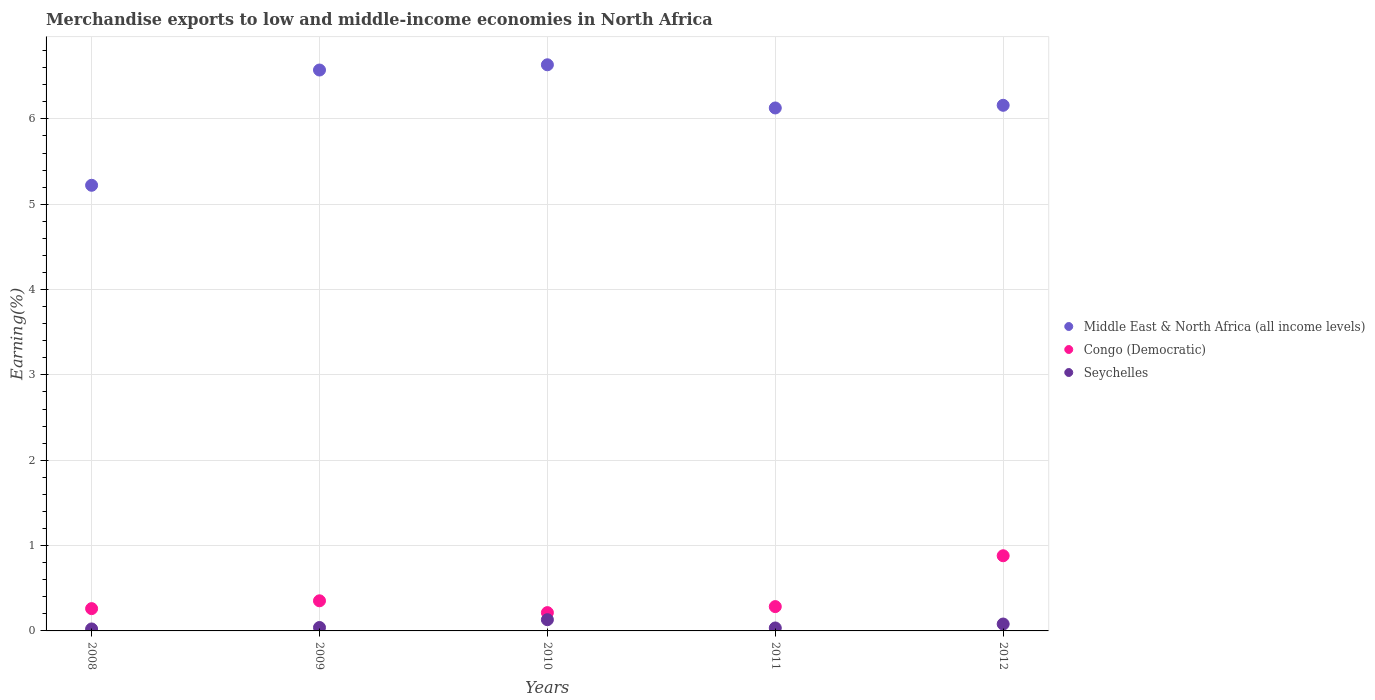What is the percentage of amount earned from merchandise exports in Seychelles in 2012?
Give a very brief answer. 0.08. Across all years, what is the maximum percentage of amount earned from merchandise exports in Middle East & North Africa (all income levels)?
Offer a very short reply. 6.63. Across all years, what is the minimum percentage of amount earned from merchandise exports in Middle East & North Africa (all income levels)?
Your answer should be very brief. 5.22. What is the total percentage of amount earned from merchandise exports in Congo (Democratic) in the graph?
Ensure brevity in your answer.  1.99. What is the difference between the percentage of amount earned from merchandise exports in Middle East & North Africa (all income levels) in 2011 and that in 2012?
Provide a succinct answer. -0.03. What is the difference between the percentage of amount earned from merchandise exports in Middle East & North Africa (all income levels) in 2011 and the percentage of amount earned from merchandise exports in Congo (Democratic) in 2010?
Offer a very short reply. 5.91. What is the average percentage of amount earned from merchandise exports in Congo (Democratic) per year?
Offer a terse response. 0.4. In the year 2011, what is the difference between the percentage of amount earned from merchandise exports in Middle East & North Africa (all income levels) and percentage of amount earned from merchandise exports in Congo (Democratic)?
Give a very brief answer. 5.84. What is the ratio of the percentage of amount earned from merchandise exports in Seychelles in 2010 to that in 2012?
Offer a very short reply. 1.63. Is the percentage of amount earned from merchandise exports in Middle East & North Africa (all income levels) in 2009 less than that in 2012?
Ensure brevity in your answer.  No. Is the difference between the percentage of amount earned from merchandise exports in Middle East & North Africa (all income levels) in 2009 and 2011 greater than the difference between the percentage of amount earned from merchandise exports in Congo (Democratic) in 2009 and 2011?
Make the answer very short. Yes. What is the difference between the highest and the second highest percentage of amount earned from merchandise exports in Middle East & North Africa (all income levels)?
Provide a succinct answer. 0.06. What is the difference between the highest and the lowest percentage of amount earned from merchandise exports in Middle East & North Africa (all income levels)?
Provide a succinct answer. 1.41. Does the percentage of amount earned from merchandise exports in Congo (Democratic) monotonically increase over the years?
Your answer should be very brief. No. Is the percentage of amount earned from merchandise exports in Middle East & North Africa (all income levels) strictly less than the percentage of amount earned from merchandise exports in Seychelles over the years?
Make the answer very short. No. How many dotlines are there?
Your answer should be compact. 3. How many years are there in the graph?
Give a very brief answer. 5. What is the difference between two consecutive major ticks on the Y-axis?
Your answer should be compact. 1. Are the values on the major ticks of Y-axis written in scientific E-notation?
Give a very brief answer. No. Where does the legend appear in the graph?
Offer a very short reply. Center right. What is the title of the graph?
Ensure brevity in your answer.  Merchandise exports to low and middle-income economies in North Africa. What is the label or title of the Y-axis?
Offer a terse response. Earning(%). What is the Earning(%) in Middle East & North Africa (all income levels) in 2008?
Your answer should be compact. 5.22. What is the Earning(%) in Congo (Democratic) in 2008?
Provide a succinct answer. 0.26. What is the Earning(%) in Seychelles in 2008?
Make the answer very short. 0.02. What is the Earning(%) of Middle East & North Africa (all income levels) in 2009?
Give a very brief answer. 6.57. What is the Earning(%) of Congo (Democratic) in 2009?
Provide a succinct answer. 0.35. What is the Earning(%) in Seychelles in 2009?
Your answer should be compact. 0.04. What is the Earning(%) of Middle East & North Africa (all income levels) in 2010?
Keep it short and to the point. 6.63. What is the Earning(%) of Congo (Democratic) in 2010?
Your response must be concise. 0.21. What is the Earning(%) of Seychelles in 2010?
Ensure brevity in your answer.  0.13. What is the Earning(%) in Middle East & North Africa (all income levels) in 2011?
Your response must be concise. 6.13. What is the Earning(%) of Congo (Democratic) in 2011?
Offer a terse response. 0.28. What is the Earning(%) in Seychelles in 2011?
Provide a short and direct response. 0.03. What is the Earning(%) in Middle East & North Africa (all income levels) in 2012?
Provide a succinct answer. 6.16. What is the Earning(%) in Congo (Democratic) in 2012?
Make the answer very short. 0.88. What is the Earning(%) in Seychelles in 2012?
Ensure brevity in your answer.  0.08. Across all years, what is the maximum Earning(%) in Middle East & North Africa (all income levels)?
Give a very brief answer. 6.63. Across all years, what is the maximum Earning(%) in Congo (Democratic)?
Your response must be concise. 0.88. Across all years, what is the maximum Earning(%) in Seychelles?
Ensure brevity in your answer.  0.13. Across all years, what is the minimum Earning(%) in Middle East & North Africa (all income levels)?
Make the answer very short. 5.22. Across all years, what is the minimum Earning(%) in Congo (Democratic)?
Offer a terse response. 0.21. Across all years, what is the minimum Earning(%) in Seychelles?
Keep it short and to the point. 0.02. What is the total Earning(%) of Middle East & North Africa (all income levels) in the graph?
Your response must be concise. 30.72. What is the total Earning(%) of Congo (Democratic) in the graph?
Your response must be concise. 1.99. What is the total Earning(%) of Seychelles in the graph?
Keep it short and to the point. 0.31. What is the difference between the Earning(%) in Middle East & North Africa (all income levels) in 2008 and that in 2009?
Offer a very short reply. -1.35. What is the difference between the Earning(%) in Congo (Democratic) in 2008 and that in 2009?
Provide a short and direct response. -0.09. What is the difference between the Earning(%) in Seychelles in 2008 and that in 2009?
Keep it short and to the point. -0.02. What is the difference between the Earning(%) of Middle East & North Africa (all income levels) in 2008 and that in 2010?
Your answer should be very brief. -1.41. What is the difference between the Earning(%) of Congo (Democratic) in 2008 and that in 2010?
Provide a succinct answer. 0.05. What is the difference between the Earning(%) in Seychelles in 2008 and that in 2010?
Keep it short and to the point. -0.11. What is the difference between the Earning(%) of Middle East & North Africa (all income levels) in 2008 and that in 2011?
Your answer should be compact. -0.91. What is the difference between the Earning(%) of Congo (Democratic) in 2008 and that in 2011?
Your response must be concise. -0.02. What is the difference between the Earning(%) of Seychelles in 2008 and that in 2011?
Your answer should be very brief. -0.01. What is the difference between the Earning(%) in Middle East & North Africa (all income levels) in 2008 and that in 2012?
Keep it short and to the point. -0.94. What is the difference between the Earning(%) in Congo (Democratic) in 2008 and that in 2012?
Offer a very short reply. -0.62. What is the difference between the Earning(%) of Seychelles in 2008 and that in 2012?
Give a very brief answer. -0.06. What is the difference between the Earning(%) in Middle East & North Africa (all income levels) in 2009 and that in 2010?
Ensure brevity in your answer.  -0.06. What is the difference between the Earning(%) of Congo (Democratic) in 2009 and that in 2010?
Make the answer very short. 0.14. What is the difference between the Earning(%) in Seychelles in 2009 and that in 2010?
Give a very brief answer. -0.09. What is the difference between the Earning(%) in Middle East & North Africa (all income levels) in 2009 and that in 2011?
Provide a succinct answer. 0.44. What is the difference between the Earning(%) in Congo (Democratic) in 2009 and that in 2011?
Make the answer very short. 0.07. What is the difference between the Earning(%) of Seychelles in 2009 and that in 2011?
Give a very brief answer. 0.01. What is the difference between the Earning(%) in Middle East & North Africa (all income levels) in 2009 and that in 2012?
Provide a succinct answer. 0.41. What is the difference between the Earning(%) in Congo (Democratic) in 2009 and that in 2012?
Ensure brevity in your answer.  -0.53. What is the difference between the Earning(%) in Seychelles in 2009 and that in 2012?
Keep it short and to the point. -0.04. What is the difference between the Earning(%) in Middle East & North Africa (all income levels) in 2010 and that in 2011?
Your answer should be compact. 0.51. What is the difference between the Earning(%) in Congo (Democratic) in 2010 and that in 2011?
Make the answer very short. -0.07. What is the difference between the Earning(%) of Seychelles in 2010 and that in 2011?
Your response must be concise. 0.1. What is the difference between the Earning(%) of Middle East & North Africa (all income levels) in 2010 and that in 2012?
Your answer should be compact. 0.47. What is the difference between the Earning(%) of Congo (Democratic) in 2010 and that in 2012?
Your answer should be very brief. -0.67. What is the difference between the Earning(%) in Seychelles in 2010 and that in 2012?
Make the answer very short. 0.05. What is the difference between the Earning(%) in Middle East & North Africa (all income levels) in 2011 and that in 2012?
Make the answer very short. -0.03. What is the difference between the Earning(%) in Congo (Democratic) in 2011 and that in 2012?
Offer a terse response. -0.6. What is the difference between the Earning(%) in Seychelles in 2011 and that in 2012?
Provide a short and direct response. -0.05. What is the difference between the Earning(%) in Middle East & North Africa (all income levels) in 2008 and the Earning(%) in Congo (Democratic) in 2009?
Offer a very short reply. 4.87. What is the difference between the Earning(%) in Middle East & North Africa (all income levels) in 2008 and the Earning(%) in Seychelles in 2009?
Provide a short and direct response. 5.18. What is the difference between the Earning(%) of Congo (Democratic) in 2008 and the Earning(%) of Seychelles in 2009?
Give a very brief answer. 0.22. What is the difference between the Earning(%) of Middle East & North Africa (all income levels) in 2008 and the Earning(%) of Congo (Democratic) in 2010?
Offer a terse response. 5.01. What is the difference between the Earning(%) in Middle East & North Africa (all income levels) in 2008 and the Earning(%) in Seychelles in 2010?
Your answer should be very brief. 5.09. What is the difference between the Earning(%) in Congo (Democratic) in 2008 and the Earning(%) in Seychelles in 2010?
Keep it short and to the point. 0.13. What is the difference between the Earning(%) in Middle East & North Africa (all income levels) in 2008 and the Earning(%) in Congo (Democratic) in 2011?
Provide a succinct answer. 4.94. What is the difference between the Earning(%) of Middle East & North Africa (all income levels) in 2008 and the Earning(%) of Seychelles in 2011?
Provide a succinct answer. 5.19. What is the difference between the Earning(%) in Congo (Democratic) in 2008 and the Earning(%) in Seychelles in 2011?
Your answer should be compact. 0.23. What is the difference between the Earning(%) in Middle East & North Africa (all income levels) in 2008 and the Earning(%) in Congo (Democratic) in 2012?
Keep it short and to the point. 4.34. What is the difference between the Earning(%) of Middle East & North Africa (all income levels) in 2008 and the Earning(%) of Seychelles in 2012?
Your response must be concise. 5.14. What is the difference between the Earning(%) in Congo (Democratic) in 2008 and the Earning(%) in Seychelles in 2012?
Your response must be concise. 0.18. What is the difference between the Earning(%) in Middle East & North Africa (all income levels) in 2009 and the Earning(%) in Congo (Democratic) in 2010?
Your answer should be very brief. 6.36. What is the difference between the Earning(%) of Middle East & North Africa (all income levels) in 2009 and the Earning(%) of Seychelles in 2010?
Your answer should be very brief. 6.44. What is the difference between the Earning(%) of Congo (Democratic) in 2009 and the Earning(%) of Seychelles in 2010?
Offer a terse response. 0.22. What is the difference between the Earning(%) of Middle East & North Africa (all income levels) in 2009 and the Earning(%) of Congo (Democratic) in 2011?
Offer a very short reply. 6.29. What is the difference between the Earning(%) of Middle East & North Africa (all income levels) in 2009 and the Earning(%) of Seychelles in 2011?
Give a very brief answer. 6.54. What is the difference between the Earning(%) of Congo (Democratic) in 2009 and the Earning(%) of Seychelles in 2011?
Your answer should be very brief. 0.32. What is the difference between the Earning(%) in Middle East & North Africa (all income levels) in 2009 and the Earning(%) in Congo (Democratic) in 2012?
Your response must be concise. 5.69. What is the difference between the Earning(%) in Middle East & North Africa (all income levels) in 2009 and the Earning(%) in Seychelles in 2012?
Offer a very short reply. 6.49. What is the difference between the Earning(%) of Congo (Democratic) in 2009 and the Earning(%) of Seychelles in 2012?
Your answer should be compact. 0.27. What is the difference between the Earning(%) in Middle East & North Africa (all income levels) in 2010 and the Earning(%) in Congo (Democratic) in 2011?
Give a very brief answer. 6.35. What is the difference between the Earning(%) of Middle East & North Africa (all income levels) in 2010 and the Earning(%) of Seychelles in 2011?
Your answer should be very brief. 6.6. What is the difference between the Earning(%) of Congo (Democratic) in 2010 and the Earning(%) of Seychelles in 2011?
Give a very brief answer. 0.18. What is the difference between the Earning(%) in Middle East & North Africa (all income levels) in 2010 and the Earning(%) in Congo (Democratic) in 2012?
Give a very brief answer. 5.75. What is the difference between the Earning(%) of Middle East & North Africa (all income levels) in 2010 and the Earning(%) of Seychelles in 2012?
Your answer should be very brief. 6.55. What is the difference between the Earning(%) in Congo (Democratic) in 2010 and the Earning(%) in Seychelles in 2012?
Your answer should be very brief. 0.13. What is the difference between the Earning(%) of Middle East & North Africa (all income levels) in 2011 and the Earning(%) of Congo (Democratic) in 2012?
Offer a very short reply. 5.25. What is the difference between the Earning(%) in Middle East & North Africa (all income levels) in 2011 and the Earning(%) in Seychelles in 2012?
Your response must be concise. 6.05. What is the difference between the Earning(%) in Congo (Democratic) in 2011 and the Earning(%) in Seychelles in 2012?
Ensure brevity in your answer.  0.2. What is the average Earning(%) in Middle East & North Africa (all income levels) per year?
Keep it short and to the point. 6.14. What is the average Earning(%) of Congo (Democratic) per year?
Your answer should be compact. 0.4. What is the average Earning(%) in Seychelles per year?
Ensure brevity in your answer.  0.06. In the year 2008, what is the difference between the Earning(%) in Middle East & North Africa (all income levels) and Earning(%) in Congo (Democratic)?
Ensure brevity in your answer.  4.96. In the year 2008, what is the difference between the Earning(%) in Middle East & North Africa (all income levels) and Earning(%) in Seychelles?
Give a very brief answer. 5.2. In the year 2008, what is the difference between the Earning(%) of Congo (Democratic) and Earning(%) of Seychelles?
Provide a short and direct response. 0.24. In the year 2009, what is the difference between the Earning(%) in Middle East & North Africa (all income levels) and Earning(%) in Congo (Democratic)?
Your response must be concise. 6.22. In the year 2009, what is the difference between the Earning(%) in Middle East & North Africa (all income levels) and Earning(%) in Seychelles?
Make the answer very short. 6.53. In the year 2009, what is the difference between the Earning(%) of Congo (Democratic) and Earning(%) of Seychelles?
Your answer should be very brief. 0.31. In the year 2010, what is the difference between the Earning(%) of Middle East & North Africa (all income levels) and Earning(%) of Congo (Democratic)?
Give a very brief answer. 6.42. In the year 2010, what is the difference between the Earning(%) in Middle East & North Africa (all income levels) and Earning(%) in Seychelles?
Ensure brevity in your answer.  6.5. In the year 2010, what is the difference between the Earning(%) of Congo (Democratic) and Earning(%) of Seychelles?
Give a very brief answer. 0.08. In the year 2011, what is the difference between the Earning(%) of Middle East & North Africa (all income levels) and Earning(%) of Congo (Democratic)?
Provide a succinct answer. 5.84. In the year 2011, what is the difference between the Earning(%) of Middle East & North Africa (all income levels) and Earning(%) of Seychelles?
Ensure brevity in your answer.  6.09. In the year 2011, what is the difference between the Earning(%) of Congo (Democratic) and Earning(%) of Seychelles?
Offer a terse response. 0.25. In the year 2012, what is the difference between the Earning(%) of Middle East & North Africa (all income levels) and Earning(%) of Congo (Democratic)?
Your response must be concise. 5.28. In the year 2012, what is the difference between the Earning(%) of Middle East & North Africa (all income levels) and Earning(%) of Seychelles?
Your answer should be very brief. 6.08. What is the ratio of the Earning(%) of Middle East & North Africa (all income levels) in 2008 to that in 2009?
Provide a succinct answer. 0.79. What is the ratio of the Earning(%) in Congo (Democratic) in 2008 to that in 2009?
Your answer should be compact. 0.74. What is the ratio of the Earning(%) of Seychelles in 2008 to that in 2009?
Your response must be concise. 0.58. What is the ratio of the Earning(%) of Middle East & North Africa (all income levels) in 2008 to that in 2010?
Ensure brevity in your answer.  0.79. What is the ratio of the Earning(%) of Congo (Democratic) in 2008 to that in 2010?
Your answer should be compact. 1.22. What is the ratio of the Earning(%) of Seychelles in 2008 to that in 2010?
Keep it short and to the point. 0.18. What is the ratio of the Earning(%) of Middle East & North Africa (all income levels) in 2008 to that in 2011?
Ensure brevity in your answer.  0.85. What is the ratio of the Earning(%) of Congo (Democratic) in 2008 to that in 2011?
Ensure brevity in your answer.  0.92. What is the ratio of the Earning(%) in Seychelles in 2008 to that in 2011?
Make the answer very short. 0.67. What is the ratio of the Earning(%) of Middle East & North Africa (all income levels) in 2008 to that in 2012?
Keep it short and to the point. 0.85. What is the ratio of the Earning(%) in Congo (Democratic) in 2008 to that in 2012?
Provide a succinct answer. 0.3. What is the ratio of the Earning(%) in Seychelles in 2008 to that in 2012?
Your response must be concise. 0.29. What is the ratio of the Earning(%) in Congo (Democratic) in 2009 to that in 2010?
Give a very brief answer. 1.65. What is the ratio of the Earning(%) in Seychelles in 2009 to that in 2010?
Make the answer very short. 0.3. What is the ratio of the Earning(%) of Middle East & North Africa (all income levels) in 2009 to that in 2011?
Your answer should be compact. 1.07. What is the ratio of the Earning(%) in Congo (Democratic) in 2009 to that in 2011?
Your answer should be compact. 1.24. What is the ratio of the Earning(%) in Seychelles in 2009 to that in 2011?
Make the answer very short. 1.16. What is the ratio of the Earning(%) in Middle East & North Africa (all income levels) in 2009 to that in 2012?
Provide a short and direct response. 1.07. What is the ratio of the Earning(%) in Congo (Democratic) in 2009 to that in 2012?
Offer a terse response. 0.4. What is the ratio of the Earning(%) of Seychelles in 2009 to that in 2012?
Provide a succinct answer. 0.5. What is the ratio of the Earning(%) of Middle East & North Africa (all income levels) in 2010 to that in 2011?
Provide a short and direct response. 1.08. What is the ratio of the Earning(%) of Congo (Democratic) in 2010 to that in 2011?
Give a very brief answer. 0.75. What is the ratio of the Earning(%) of Seychelles in 2010 to that in 2011?
Provide a short and direct response. 3.8. What is the ratio of the Earning(%) of Middle East & North Africa (all income levels) in 2010 to that in 2012?
Keep it short and to the point. 1.08. What is the ratio of the Earning(%) of Congo (Democratic) in 2010 to that in 2012?
Your answer should be very brief. 0.24. What is the ratio of the Earning(%) of Seychelles in 2010 to that in 2012?
Your answer should be compact. 1.63. What is the ratio of the Earning(%) of Congo (Democratic) in 2011 to that in 2012?
Provide a short and direct response. 0.32. What is the ratio of the Earning(%) of Seychelles in 2011 to that in 2012?
Offer a terse response. 0.43. What is the difference between the highest and the second highest Earning(%) of Middle East & North Africa (all income levels)?
Offer a terse response. 0.06. What is the difference between the highest and the second highest Earning(%) of Congo (Democratic)?
Ensure brevity in your answer.  0.53. What is the difference between the highest and the second highest Earning(%) of Seychelles?
Your response must be concise. 0.05. What is the difference between the highest and the lowest Earning(%) of Middle East & North Africa (all income levels)?
Ensure brevity in your answer.  1.41. What is the difference between the highest and the lowest Earning(%) of Congo (Democratic)?
Your answer should be compact. 0.67. What is the difference between the highest and the lowest Earning(%) of Seychelles?
Your response must be concise. 0.11. 